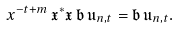<formula> <loc_0><loc_0><loc_500><loc_500>x ^ { - t + m } \, \mathfrak { x } ^ { * } \mathfrak { x } \, \mathfrak { b } \, \mathfrak { u } _ { n , t } = \mathfrak { b } \, \mathfrak { u } _ { n , t } .</formula> 